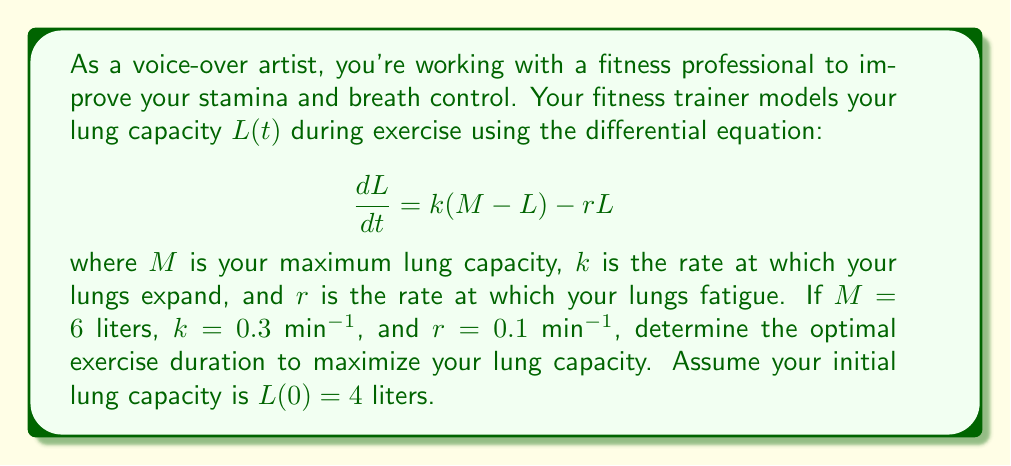Can you answer this question? To solve this problem, we need to follow these steps:

1. Solve the differential equation to find $L(t)$.
2. Find the limit of $L(t)$ as $t$ approaches infinity.
3. Determine the time it takes to reach 95% of the limit.

Step 1: Solving the differential equation

The given differential equation is:

$$\frac{dL}{dt} = k(M - L) - rL$$

Rearranging the terms:

$$\frac{dL}{dt} = kM - (k+r)L$$

This is a first-order linear differential equation. The solution is:

$$L(t) = \frac{kM}{k+r} + \left(L(0) - \frac{kM}{k+r}\right)e^{-(k+r)t}$$

Substituting the given values:

$$L(t) = \frac{0.3 \cdot 6}{0.3 + 0.1} + \left(4 - \frac{0.3 \cdot 6}{0.3 + 0.1}\right)e^{-(0.3+0.1)t}$$

$$L(t) = 4.5 + (4 - 4.5)e^{-0.4t}$$

$$L(t) = 4.5 - 0.5e^{-0.4t}$$

Step 2: Finding the limit as t approaches infinity

As $t$ approaches infinity, $e^{-0.4t}$ approaches 0. Therefore:

$$\lim_{t \to \infty} L(t) = 4.5$$

Step 3: Determining the time to reach 95% of the limit

We want to find $t$ when $L(t)$ reaches 95% of 4.5 liters:

$$0.95 \cdot 4.5 = 4.5 - 0.5e^{-0.4t}$$

$$4.275 = 4.5 - 0.5e^{-0.4t}$$

$$0.225 = 0.5e^{-0.4t}$$

$$0.45 = e^{-0.4t}$$

$$\ln(0.45) = -0.4t$$

$$t = -\frac{\ln(0.45)}{0.4} \approx 2.01$$

Therefore, the optimal exercise duration to maximize lung capacity is approximately 2.01 minutes.
Answer: The optimal exercise duration is approximately 2.01 minutes. 